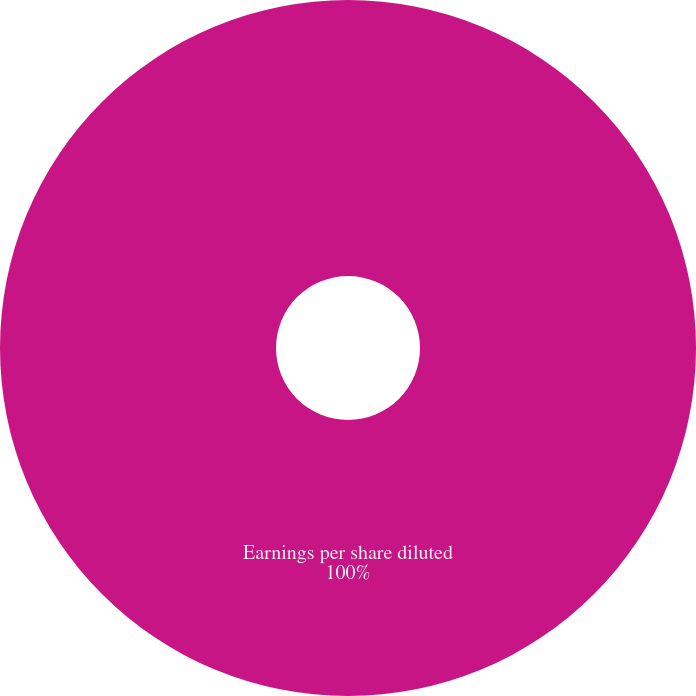<chart> <loc_0><loc_0><loc_500><loc_500><pie_chart><fcel>Earnings per share diluted<nl><fcel>100.0%<nl></chart> 